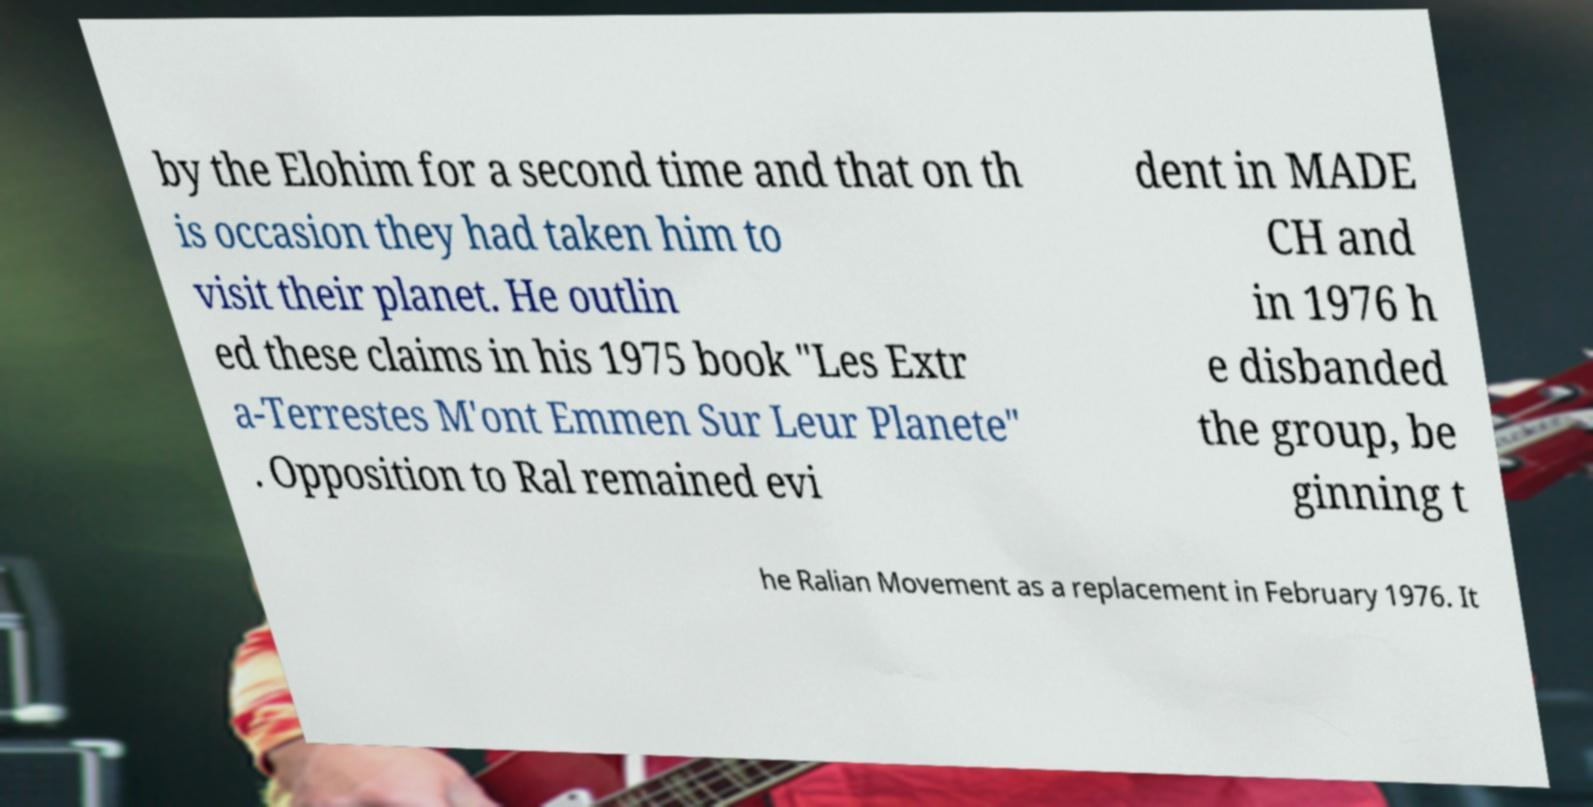Can you read and provide the text displayed in the image?This photo seems to have some interesting text. Can you extract and type it out for me? by the Elohim for a second time and that on th is occasion they had taken him to visit their planet. He outlin ed these claims in his 1975 book "Les Extr a-Terrestes M'ont Emmen Sur Leur Planete" . Opposition to Ral remained evi dent in MADE CH and in 1976 h e disbanded the group, be ginning t he Ralian Movement as a replacement in February 1976. It 